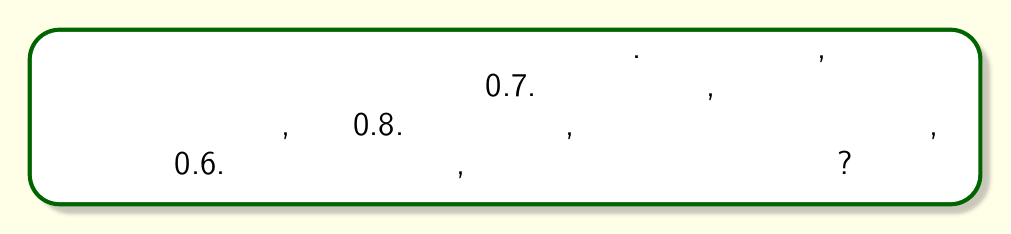Can you solve this math problem? Для решения этой задачи воспользуемся правилом умножения вероятностей для независимых событий.

Пусть:
$A$ - модуль пройдет тестирование без ошибок
$B$ - документация будет одобрена с первого раза
$C$ - клиент примет модуль без доработок

Даны вероятности:
$P(A) = 0.7$
$P(B) = 0.8$
$P(C) = 0.6$

Так как события независимы, вероятность того, что все три события произойдут, равна произведению их вероятностей:

$$P(A \cap B \cap C) = P(A) \cdot P(B) \cdot P(C)$$

Подставляем значения:

$$P(A \cap B \cap C) = 0.7 \cdot 0.8 \cdot 0.6$$

Вычисляем:

$$P(A \cap B \cap C) = 0.336$$

Таким образом, вероятность того, что все три события произойдут успешно, равна 0.336 или 33.6%.
Answer: 0.336 